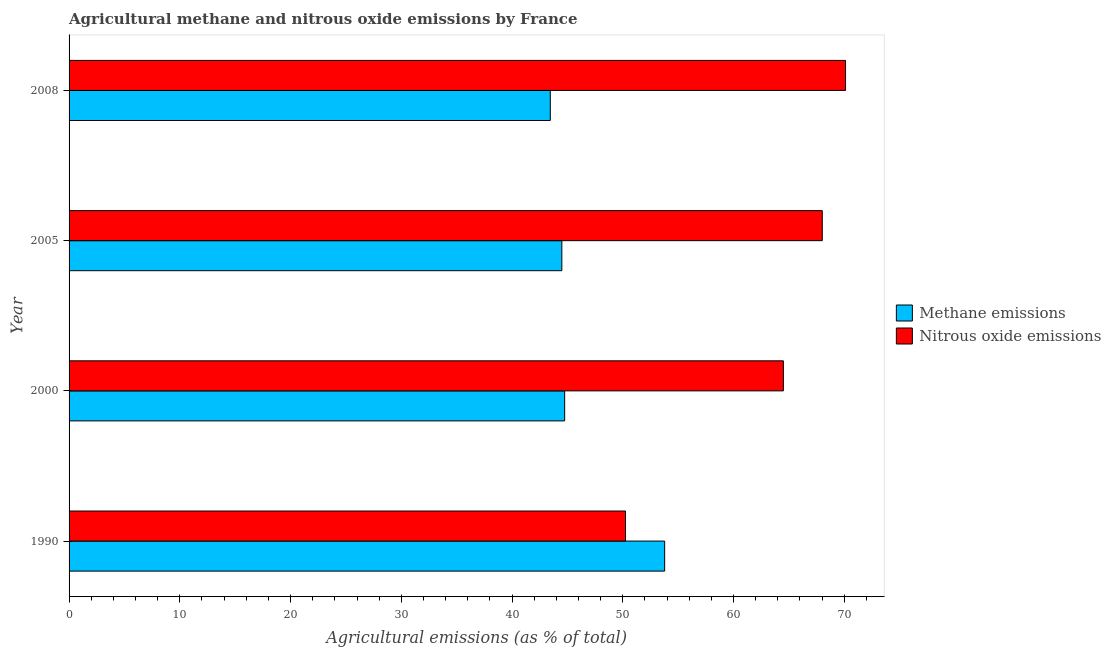How many groups of bars are there?
Your answer should be compact. 4. How many bars are there on the 3rd tick from the top?
Offer a terse response. 2. What is the label of the 2nd group of bars from the top?
Provide a short and direct response. 2005. What is the amount of nitrous oxide emissions in 2000?
Your answer should be very brief. 64.5. Across all years, what is the maximum amount of nitrous oxide emissions?
Your answer should be compact. 70.12. Across all years, what is the minimum amount of methane emissions?
Ensure brevity in your answer.  43.45. What is the total amount of nitrous oxide emissions in the graph?
Provide a succinct answer. 252.88. What is the difference between the amount of methane emissions in 2005 and that in 2008?
Offer a terse response. 1.04. What is the difference between the amount of nitrous oxide emissions in 2005 and the amount of methane emissions in 2008?
Make the answer very short. 24.56. What is the average amount of nitrous oxide emissions per year?
Your response must be concise. 63.22. In the year 1990, what is the difference between the amount of methane emissions and amount of nitrous oxide emissions?
Provide a short and direct response. 3.54. What is the ratio of the amount of nitrous oxide emissions in 2005 to that in 2008?
Offer a terse response. 0.97. Is the amount of nitrous oxide emissions in 2000 less than that in 2008?
Make the answer very short. Yes. Is the difference between the amount of nitrous oxide emissions in 1990 and 2008 greater than the difference between the amount of methane emissions in 1990 and 2008?
Offer a terse response. No. What is the difference between the highest and the second highest amount of nitrous oxide emissions?
Your answer should be compact. 2.1. What is the difference between the highest and the lowest amount of methane emissions?
Keep it short and to the point. 10.33. In how many years, is the amount of methane emissions greater than the average amount of methane emissions taken over all years?
Ensure brevity in your answer.  1. Is the sum of the amount of nitrous oxide emissions in 2000 and 2008 greater than the maximum amount of methane emissions across all years?
Provide a succinct answer. Yes. What does the 1st bar from the top in 2008 represents?
Your response must be concise. Nitrous oxide emissions. What does the 2nd bar from the bottom in 2008 represents?
Give a very brief answer. Nitrous oxide emissions. Are all the bars in the graph horizontal?
Your response must be concise. Yes. How many years are there in the graph?
Your answer should be very brief. 4. Are the values on the major ticks of X-axis written in scientific E-notation?
Your answer should be very brief. No. Does the graph contain any zero values?
Your answer should be compact. No. How many legend labels are there?
Your answer should be very brief. 2. What is the title of the graph?
Your answer should be compact. Agricultural methane and nitrous oxide emissions by France. What is the label or title of the X-axis?
Ensure brevity in your answer.  Agricultural emissions (as % of total). What is the Agricultural emissions (as % of total) of Methane emissions in 1990?
Give a very brief answer. 53.78. What is the Agricultural emissions (as % of total) of Nitrous oxide emissions in 1990?
Your answer should be very brief. 50.25. What is the Agricultural emissions (as % of total) in Methane emissions in 2000?
Your answer should be very brief. 44.75. What is the Agricultural emissions (as % of total) in Nitrous oxide emissions in 2000?
Provide a succinct answer. 64.5. What is the Agricultural emissions (as % of total) of Methane emissions in 2005?
Keep it short and to the point. 44.5. What is the Agricultural emissions (as % of total) in Nitrous oxide emissions in 2005?
Your answer should be compact. 68.02. What is the Agricultural emissions (as % of total) of Methane emissions in 2008?
Provide a succinct answer. 43.45. What is the Agricultural emissions (as % of total) of Nitrous oxide emissions in 2008?
Your answer should be very brief. 70.12. Across all years, what is the maximum Agricultural emissions (as % of total) in Methane emissions?
Give a very brief answer. 53.78. Across all years, what is the maximum Agricultural emissions (as % of total) in Nitrous oxide emissions?
Provide a short and direct response. 70.12. Across all years, what is the minimum Agricultural emissions (as % of total) in Methane emissions?
Keep it short and to the point. 43.45. Across all years, what is the minimum Agricultural emissions (as % of total) in Nitrous oxide emissions?
Provide a succinct answer. 50.25. What is the total Agricultural emissions (as % of total) of Methane emissions in the graph?
Your response must be concise. 186.49. What is the total Agricultural emissions (as % of total) in Nitrous oxide emissions in the graph?
Your answer should be compact. 252.88. What is the difference between the Agricultural emissions (as % of total) of Methane emissions in 1990 and that in 2000?
Your answer should be compact. 9.03. What is the difference between the Agricultural emissions (as % of total) of Nitrous oxide emissions in 1990 and that in 2000?
Your answer should be very brief. -14.26. What is the difference between the Agricultural emissions (as % of total) of Methane emissions in 1990 and that in 2005?
Offer a terse response. 9.28. What is the difference between the Agricultural emissions (as % of total) of Nitrous oxide emissions in 1990 and that in 2005?
Ensure brevity in your answer.  -17.77. What is the difference between the Agricultural emissions (as % of total) of Methane emissions in 1990 and that in 2008?
Give a very brief answer. 10.33. What is the difference between the Agricultural emissions (as % of total) in Nitrous oxide emissions in 1990 and that in 2008?
Keep it short and to the point. -19.87. What is the difference between the Agricultural emissions (as % of total) of Methane emissions in 2000 and that in 2005?
Provide a succinct answer. 0.26. What is the difference between the Agricultural emissions (as % of total) of Nitrous oxide emissions in 2000 and that in 2005?
Ensure brevity in your answer.  -3.51. What is the difference between the Agricultural emissions (as % of total) in Methane emissions in 2000 and that in 2008?
Provide a short and direct response. 1.3. What is the difference between the Agricultural emissions (as % of total) of Nitrous oxide emissions in 2000 and that in 2008?
Give a very brief answer. -5.61. What is the difference between the Agricultural emissions (as % of total) in Methane emissions in 2005 and that in 2008?
Your response must be concise. 1.04. What is the difference between the Agricultural emissions (as % of total) of Nitrous oxide emissions in 2005 and that in 2008?
Provide a succinct answer. -2.1. What is the difference between the Agricultural emissions (as % of total) of Methane emissions in 1990 and the Agricultural emissions (as % of total) of Nitrous oxide emissions in 2000?
Ensure brevity in your answer.  -10.72. What is the difference between the Agricultural emissions (as % of total) in Methane emissions in 1990 and the Agricultural emissions (as % of total) in Nitrous oxide emissions in 2005?
Provide a short and direct response. -14.23. What is the difference between the Agricultural emissions (as % of total) in Methane emissions in 1990 and the Agricultural emissions (as % of total) in Nitrous oxide emissions in 2008?
Offer a very short reply. -16.33. What is the difference between the Agricultural emissions (as % of total) of Methane emissions in 2000 and the Agricultural emissions (as % of total) of Nitrous oxide emissions in 2005?
Make the answer very short. -23.26. What is the difference between the Agricultural emissions (as % of total) of Methane emissions in 2000 and the Agricultural emissions (as % of total) of Nitrous oxide emissions in 2008?
Offer a very short reply. -25.36. What is the difference between the Agricultural emissions (as % of total) in Methane emissions in 2005 and the Agricultural emissions (as % of total) in Nitrous oxide emissions in 2008?
Your answer should be compact. -25.62. What is the average Agricultural emissions (as % of total) of Methane emissions per year?
Your answer should be compact. 46.62. What is the average Agricultural emissions (as % of total) of Nitrous oxide emissions per year?
Offer a terse response. 63.22. In the year 1990, what is the difference between the Agricultural emissions (as % of total) in Methane emissions and Agricultural emissions (as % of total) in Nitrous oxide emissions?
Make the answer very short. 3.54. In the year 2000, what is the difference between the Agricultural emissions (as % of total) of Methane emissions and Agricultural emissions (as % of total) of Nitrous oxide emissions?
Your response must be concise. -19.75. In the year 2005, what is the difference between the Agricultural emissions (as % of total) of Methane emissions and Agricultural emissions (as % of total) of Nitrous oxide emissions?
Offer a very short reply. -23.52. In the year 2008, what is the difference between the Agricultural emissions (as % of total) in Methane emissions and Agricultural emissions (as % of total) in Nitrous oxide emissions?
Ensure brevity in your answer.  -26.66. What is the ratio of the Agricultural emissions (as % of total) in Methane emissions in 1990 to that in 2000?
Provide a succinct answer. 1.2. What is the ratio of the Agricultural emissions (as % of total) of Nitrous oxide emissions in 1990 to that in 2000?
Give a very brief answer. 0.78. What is the ratio of the Agricultural emissions (as % of total) of Methane emissions in 1990 to that in 2005?
Provide a succinct answer. 1.21. What is the ratio of the Agricultural emissions (as % of total) of Nitrous oxide emissions in 1990 to that in 2005?
Your response must be concise. 0.74. What is the ratio of the Agricultural emissions (as % of total) in Methane emissions in 1990 to that in 2008?
Offer a very short reply. 1.24. What is the ratio of the Agricultural emissions (as % of total) in Nitrous oxide emissions in 1990 to that in 2008?
Provide a succinct answer. 0.72. What is the ratio of the Agricultural emissions (as % of total) in Methane emissions in 2000 to that in 2005?
Your answer should be compact. 1.01. What is the ratio of the Agricultural emissions (as % of total) in Nitrous oxide emissions in 2000 to that in 2005?
Ensure brevity in your answer.  0.95. What is the ratio of the Agricultural emissions (as % of total) of Methane emissions in 2000 to that in 2008?
Offer a terse response. 1.03. What is the ratio of the Agricultural emissions (as % of total) of Methane emissions in 2005 to that in 2008?
Ensure brevity in your answer.  1.02. What is the ratio of the Agricultural emissions (as % of total) in Nitrous oxide emissions in 2005 to that in 2008?
Your answer should be compact. 0.97. What is the difference between the highest and the second highest Agricultural emissions (as % of total) of Methane emissions?
Keep it short and to the point. 9.03. What is the difference between the highest and the second highest Agricultural emissions (as % of total) in Nitrous oxide emissions?
Ensure brevity in your answer.  2.1. What is the difference between the highest and the lowest Agricultural emissions (as % of total) in Methane emissions?
Ensure brevity in your answer.  10.33. What is the difference between the highest and the lowest Agricultural emissions (as % of total) in Nitrous oxide emissions?
Ensure brevity in your answer.  19.87. 